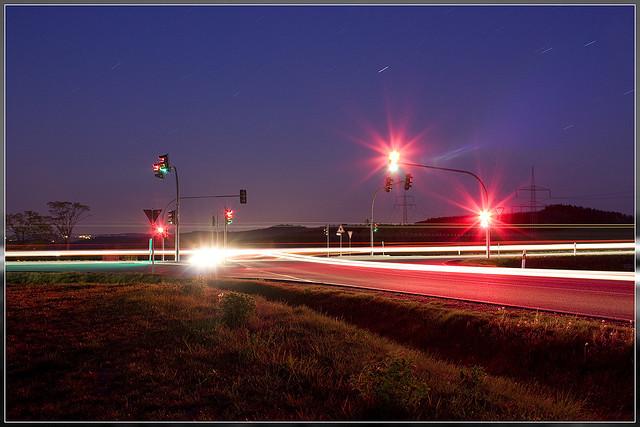Is the traffic heavy?
Quick response, please. No. Is it morning or night?
Give a very brief answer. Night. How many stop lights are there?
Keep it brief. 10. 